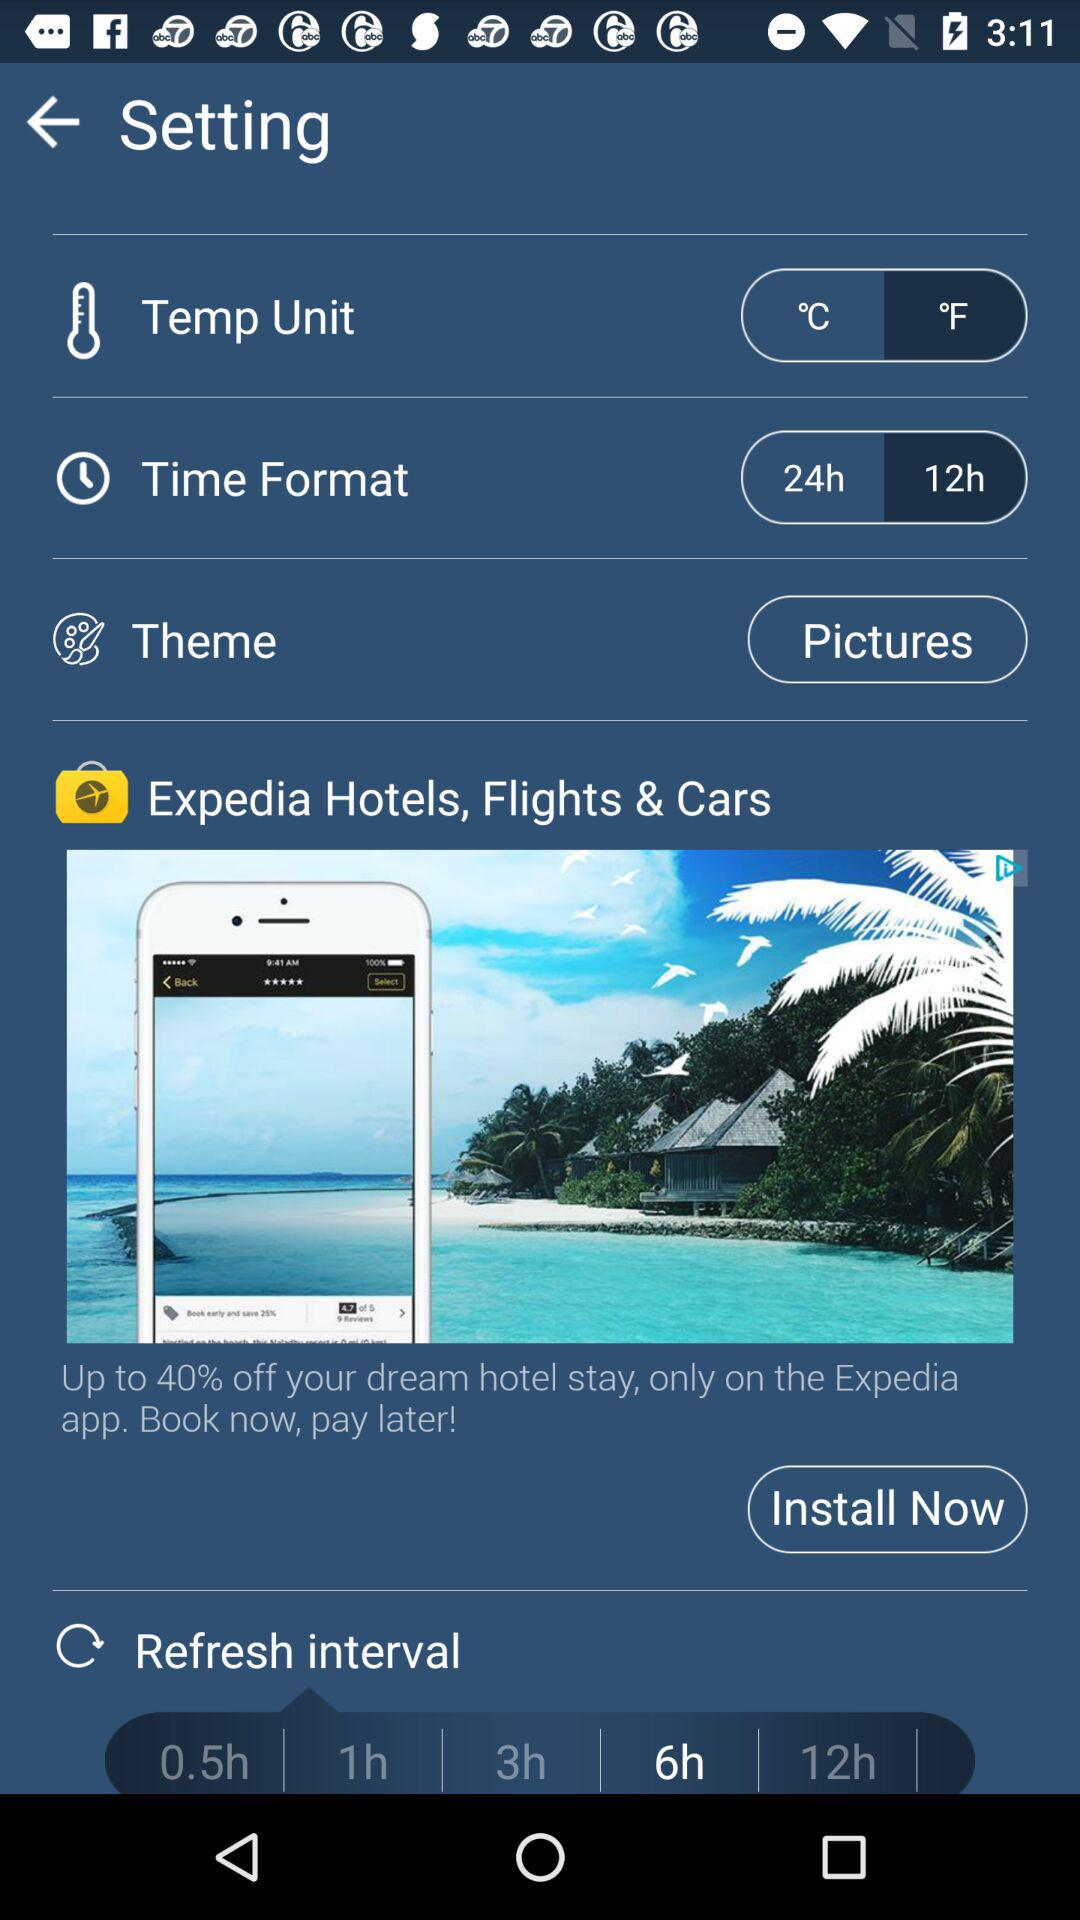What is the temperature unit? The temperature unit is °C. 